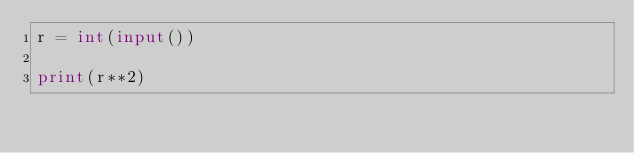<code> <loc_0><loc_0><loc_500><loc_500><_Python_>r = int(input())

print(r**2)</code> 